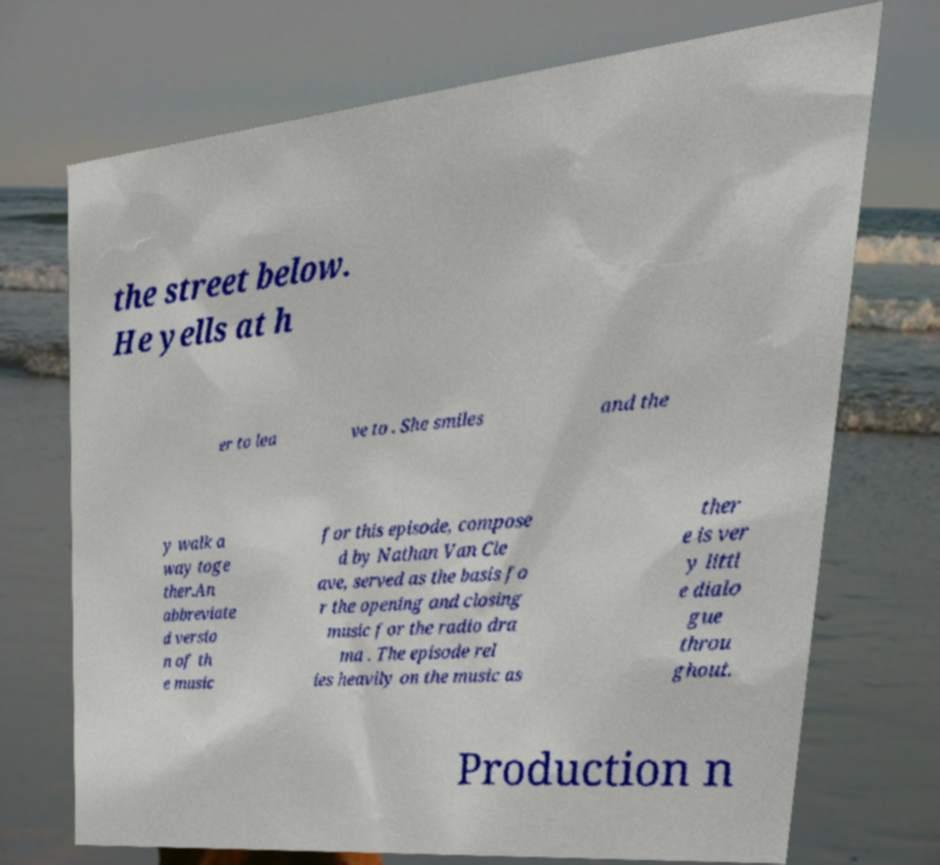Could you extract and type out the text from this image? the street below. He yells at h er to lea ve to . She smiles and the y walk a way toge ther.An abbreviate d versio n of th e music for this episode, compose d by Nathan Van Cle ave, served as the basis fo r the opening and closing music for the radio dra ma . The episode rel ies heavily on the music as ther e is ver y littl e dialo gue throu ghout. Production n 